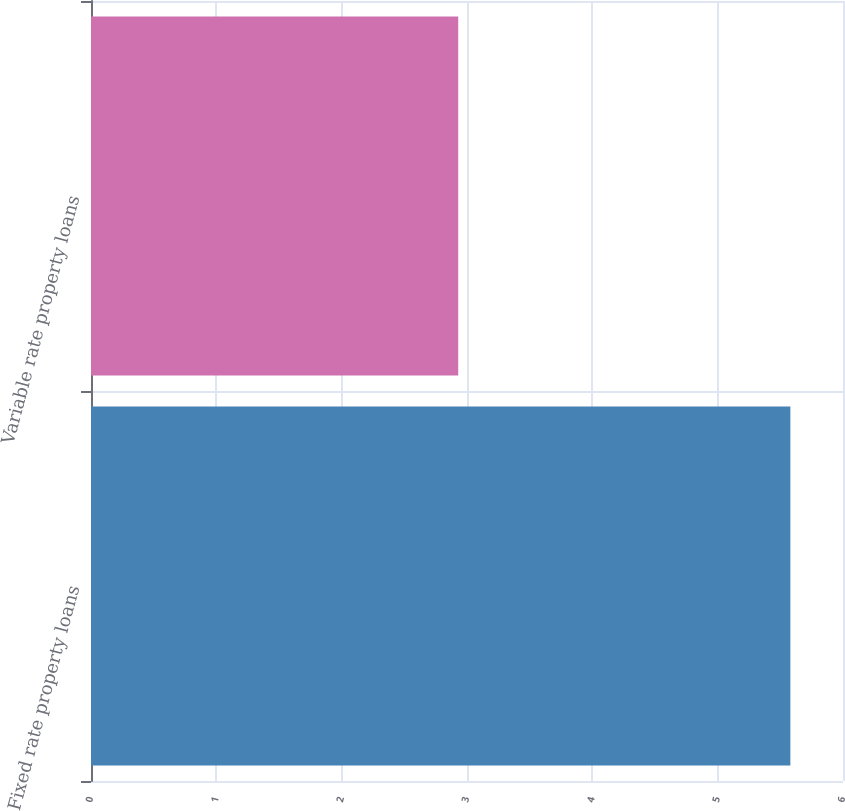Convert chart. <chart><loc_0><loc_0><loc_500><loc_500><bar_chart><fcel>Fixed rate property loans<fcel>Variable rate property loans<nl><fcel>5.58<fcel>2.93<nl></chart> 